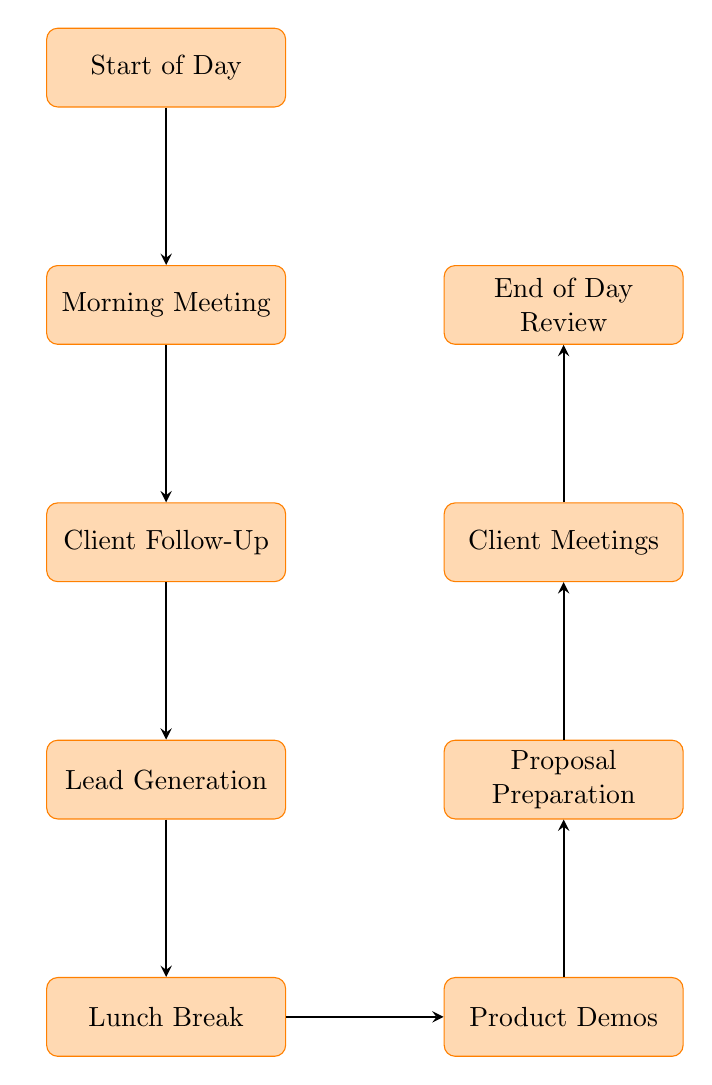What is the first task in the daily schedule? The first task in the daily schedule is indicated as the starting node of the flow chart, which is labeled "Start of Day".
Answer: Start of Day How many tasks are included in the daily work schedule? To determine the number of tasks, count the nodes in the diagram. There are a total of 9 nodes, each representing a task.
Answer: 9 What comes after the "Client Follow-Up"? By following the arrows in the diagram, "Client Follow-Up" points directly to "Lead Generation", which is the next task in the sequence.
Answer: Lead Generation What is the last task listed in the flow chart? The last task can be identified as the final node in the flow diagram, which is labeled "End of Day Review".
Answer: End of Day Review Which task involves taking a break? By examining the nodes, the task that mentions taking a break is labeled "Lunch Break".
Answer: Lunch Break What is the relationship between "Product Demos" and "Client Meetings"? "Product Demos" is a node connected to "Proposal Preparation", which in turn connects to "Client Meetings", indicating that these tasks occur sequentially.
Answer: Sequential What type of activities occur during the "Morning Meeting"? The "Morning Meeting" is described as a team huddle to discuss sales strategies, which involves collaborative discussion as the activity.
Answer: Team huddle How many tasks occur before "Lunch Break"? By tracing the nodes leading up to "Lunch Break", there are 4 preceding tasks: "Start of Day", "Morning Meeting", "Client Follow-Up", and "Lead Generation".
Answer: 4 What is the task directly preceding "Proposal Preparation"? Looking at the flow, the task that comes directly before "Proposal Preparation" is "Product Demos".
Answer: Product Demos 